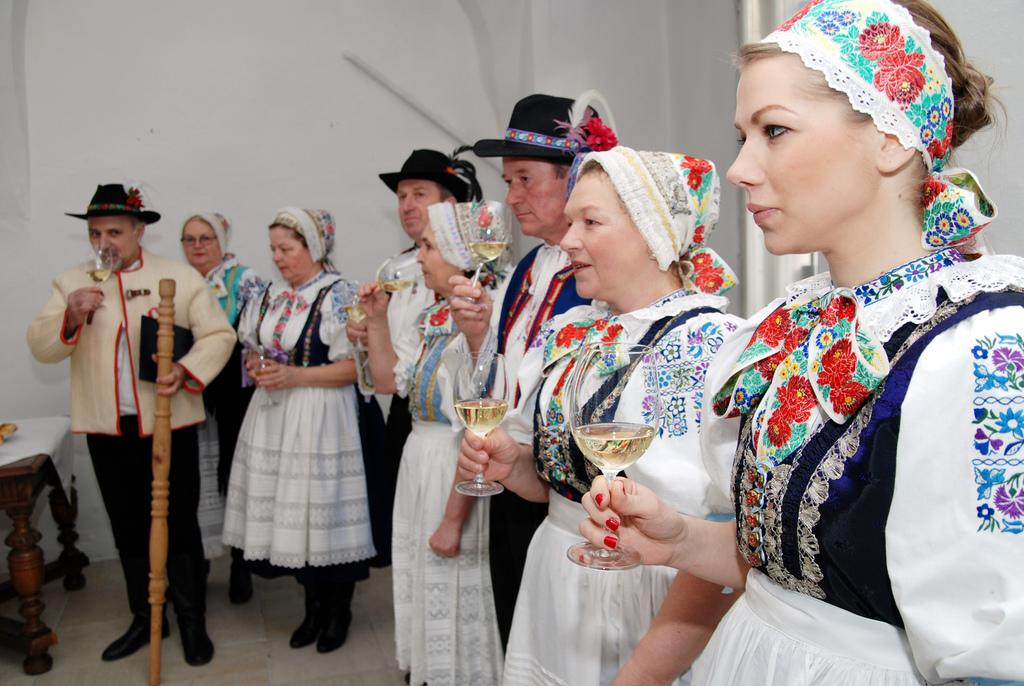What are the people in the image doing? The people in the image are standing and holding glasses. What is the man holding in the image? The man is holding a wooden object. What can be seen on the table in the image? There are objects on the table and cloth covering it. What is visible in the background of the image? There is a wall in the background of the image. What type of pigs can be seen playing with the waste in the image? There are no pigs or waste present in the image. 